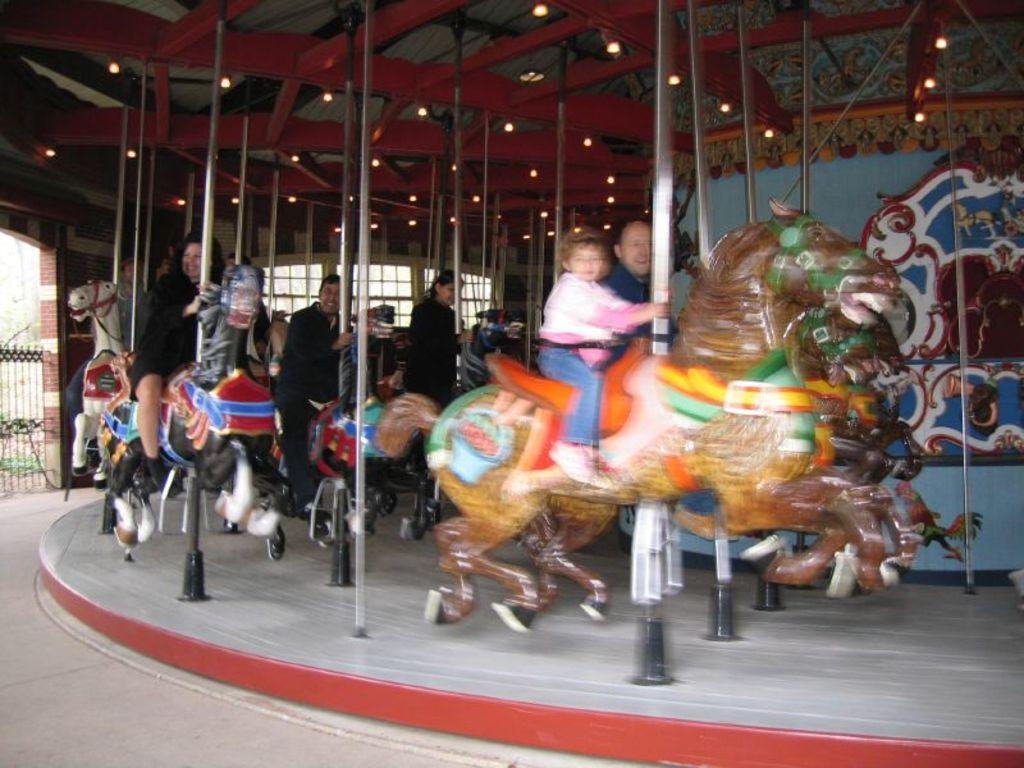How many people are in the group visible in the image? There is a group of people in the image, but the exact number cannot be determined from the provided facts. What type of ride is present in the image? There is a carousel in the image. What material are the rods made of in the image? Metal rods are visible in the image. What type of animals are depicted in the sculptures in the image? Sculptures of animals are present in the image, but the specific types of animals cannot be determined from the provided facts. What type of lighting is present in the image? Lights are observable in the image. What type of windows are visible in the image? Windows are visible in the image, but the specific type of windows cannot be determined from the provided facts. What other objects are present in the image? There are other objects in the image, but their specific nature cannot be determined from the provided facts. What type of humor is being displayed by the current in the image? There is no current present in the image, and therefore no humor can be attributed to it. 